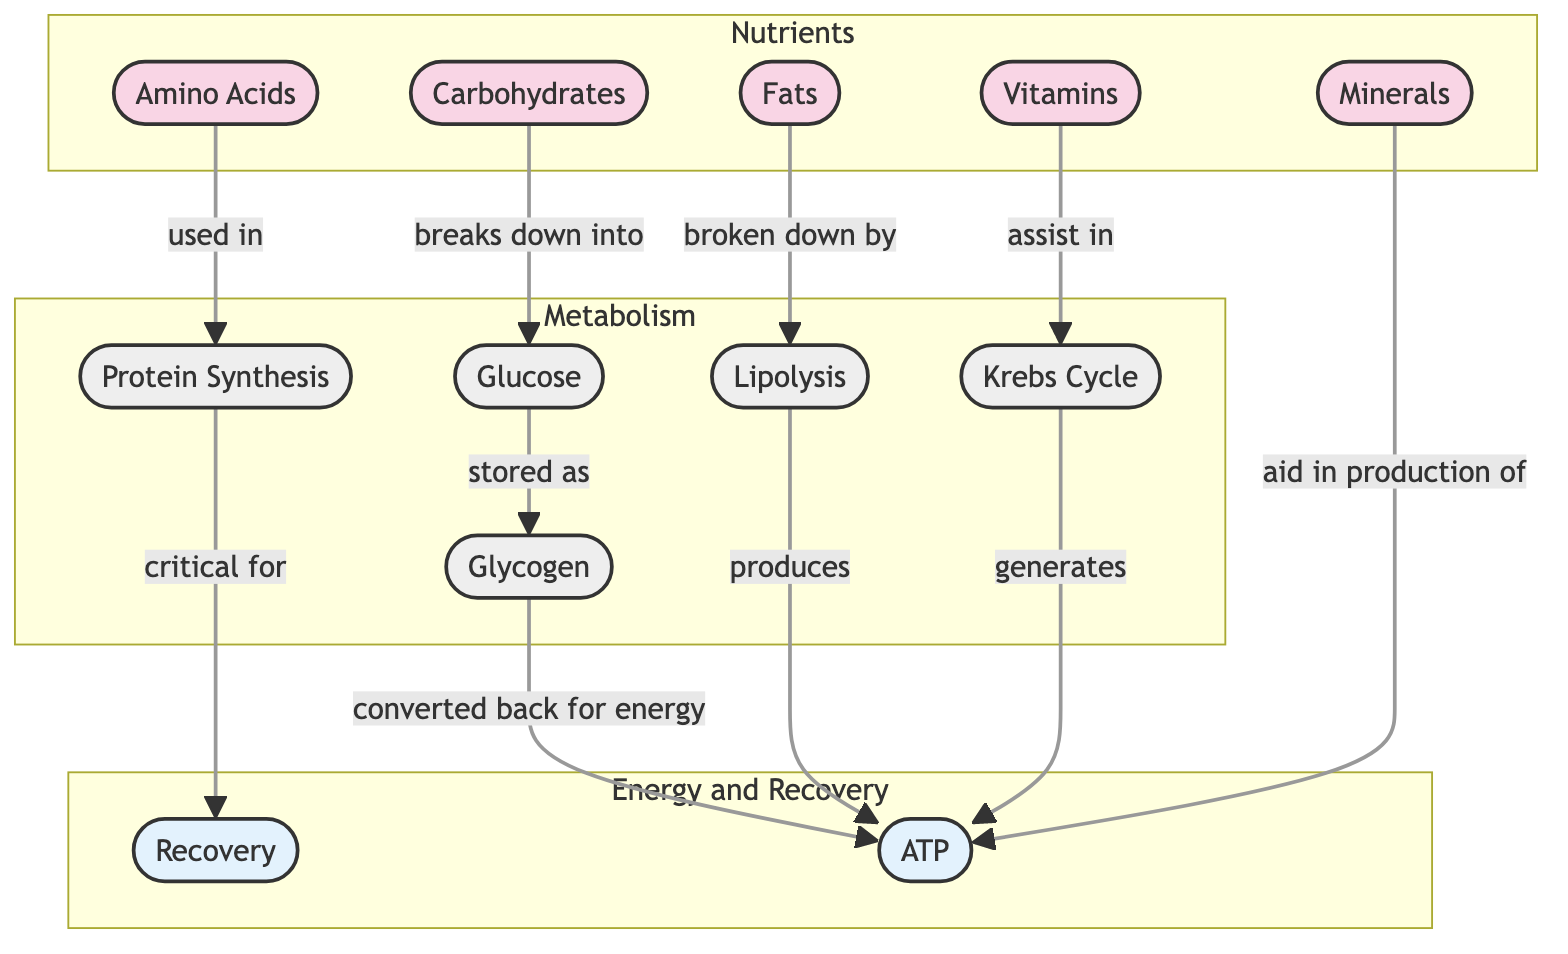What are the primary nutrients highlighted in the diagram? The diagram identifies five primary nutrients, which are amino acids, carbohydrates, fats, vitamins, and minerals.
Answer: amino acids, carbohydrates, fats, vitamins, minerals How is glucose stored in the body? The diagram shows that glucose is stored as glycogen after being broken down from carbohydrates.
Answer: glycogen What is produced from lipolysis? According to the diagram, lipolysis produces ATP as it breaks down fats.
Answer: ATP How do vitamins assist in the metabolic process? The diagram indicates that vitamins assist in the Krebs Cycle, which is crucial for energy production.
Answer: Krebs Cycle How do amino acids contribute to recovery? The diagram illustrates that amino acids are used in protein synthesis, which is critical for recovery after performance.
Answer: protein synthesis Which metabolic pathway generates ATP from glycogen? The diagram shows that glycogen is converted back for energy to produce ATP in the process labeled ATP production.
Answer: ATP What role do minerals play in energy production? The diagram states that minerals aid in the production of ATP, highlighting their importance in energy metabolism.
Answer: production of ATP What is the connection between protein synthesis and recovery? The diagram indicates that protein synthesis is critical for recovery, suggesting a direct relationship between the two processes.
Answer: critical for recovery How many primary nutrients are involved in energy production? Examining the diagram, we find that there are five primary nutrients contributing to energy production processes.
Answer: five 